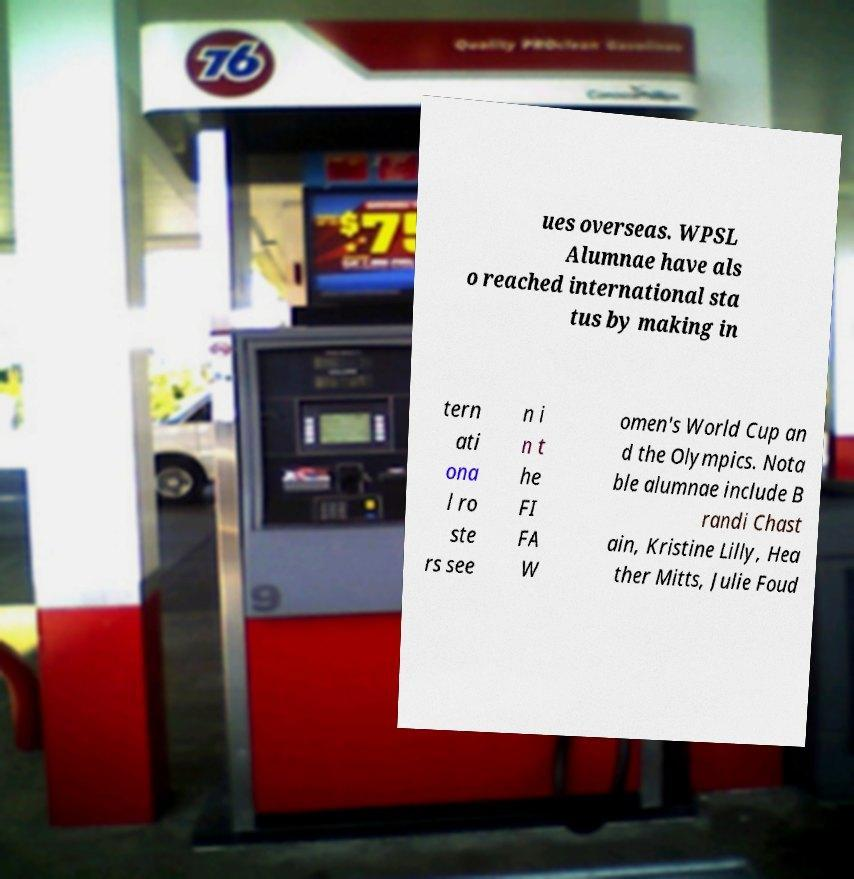Could you assist in decoding the text presented in this image and type it out clearly? ues overseas. WPSL Alumnae have als o reached international sta tus by making in tern ati ona l ro ste rs see n i n t he FI FA W omen's World Cup an d the Olympics. Nota ble alumnae include B randi Chast ain, Kristine Lilly, Hea ther Mitts, Julie Foud 